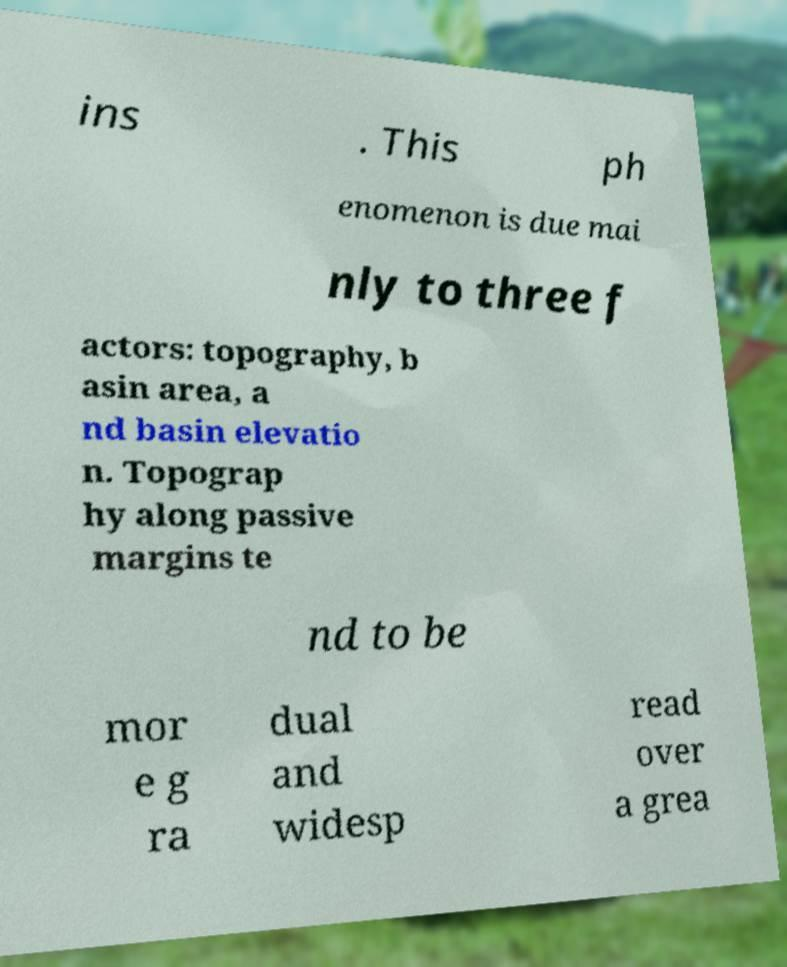Can you read and provide the text displayed in the image?This photo seems to have some interesting text. Can you extract and type it out for me? ins . This ph enomenon is due mai nly to three f actors: topography, b asin area, a nd basin elevatio n. Topograp hy along passive margins te nd to be mor e g ra dual and widesp read over a grea 